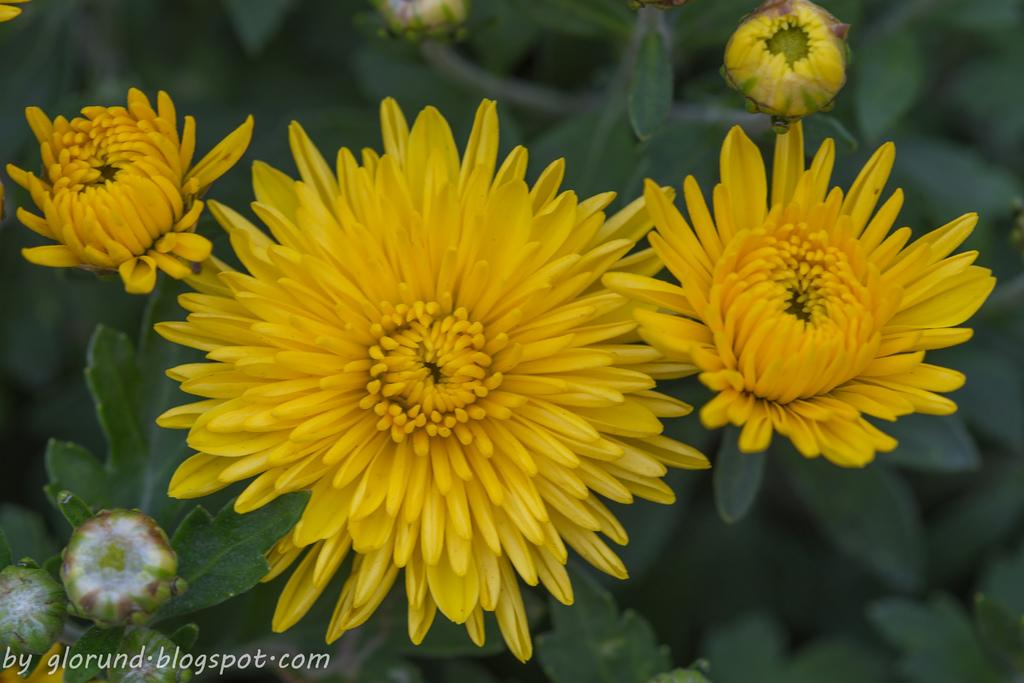What type of plants can be seen in the image? There are flowers, buds, and leaves in the image. Can you describe the growth stage of the plants in the image? The image shows both buds and flowers, indicating that the plants are in various stages of growth. What part of the plants is visible in the image? The image shows leaves, flowers, and buds. How many laps can the juice swim in the image? There is no juice present in the image, and therefore no swimming activity can be observed. 